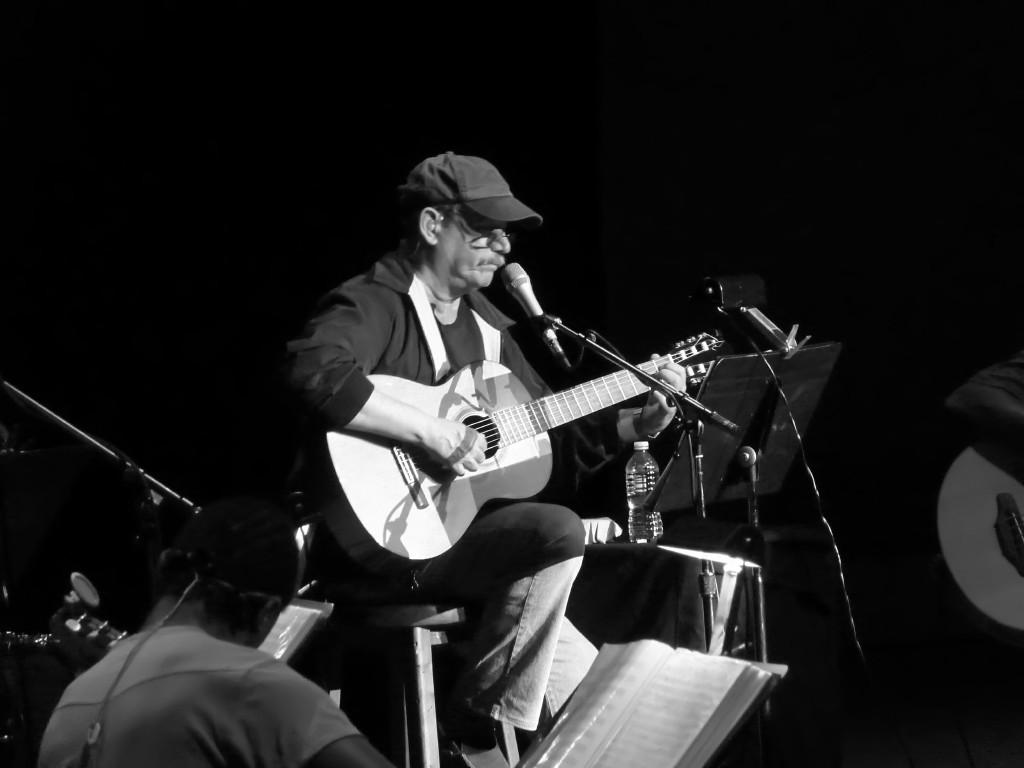Who is present in the image? There is a man in the image. What is the man doing in the image? The man is sitting in the image. What object is the man holding in the image? The man is holding a guitar in his hand. What is the color scheme of the image? The image is in black and white color. What type of lead is the man using to play the guitar in the image? There is no indication of the type of lead being used in the image, as it is in black and white and does not show any details about the guitar or its accessories. 